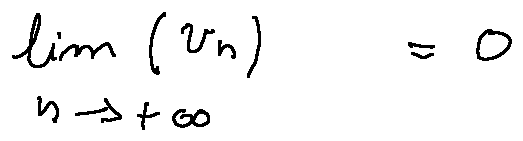Convert formula to latex. <formula><loc_0><loc_0><loc_500><loc_500>\lim \lim i t s _ { n \rightarrow + \infty } ( u _ { n } ) = 0</formula> 